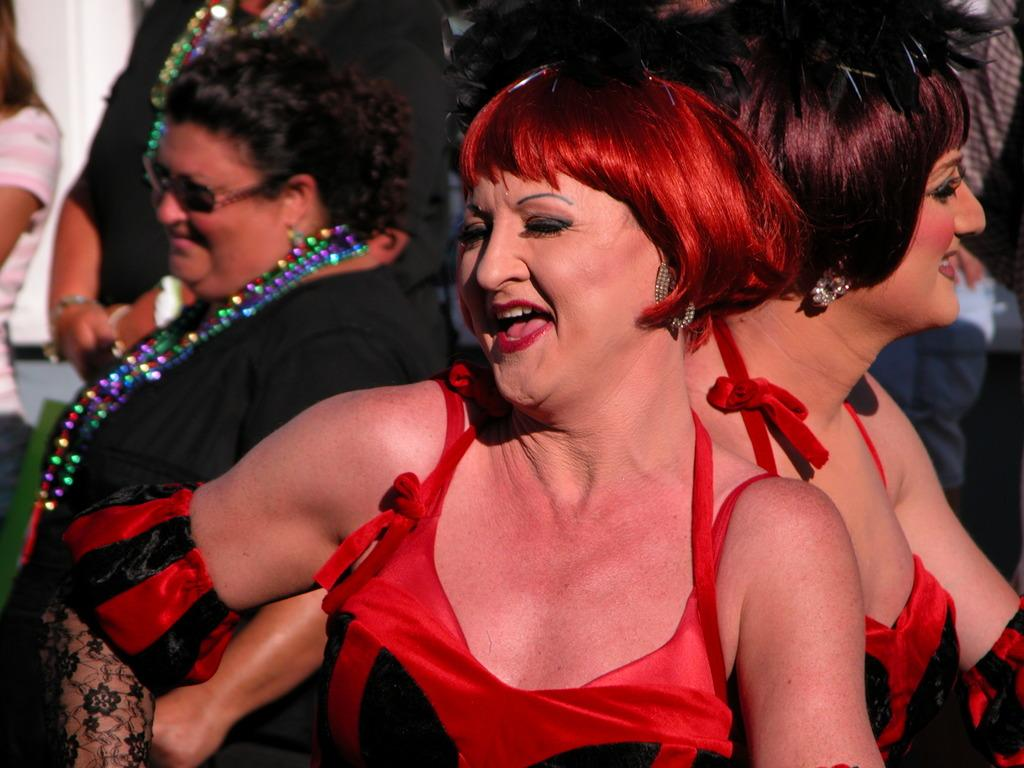What are the two ladies in the foreground of the image doing? The two ladies in the foreground of the image are dancing. Can you describe the background of the image? There are people in the background of the image. What type of grape is being used as a prop by one of the ladies in the image? There is no grape present in the image, and neither lady is using any prop. 